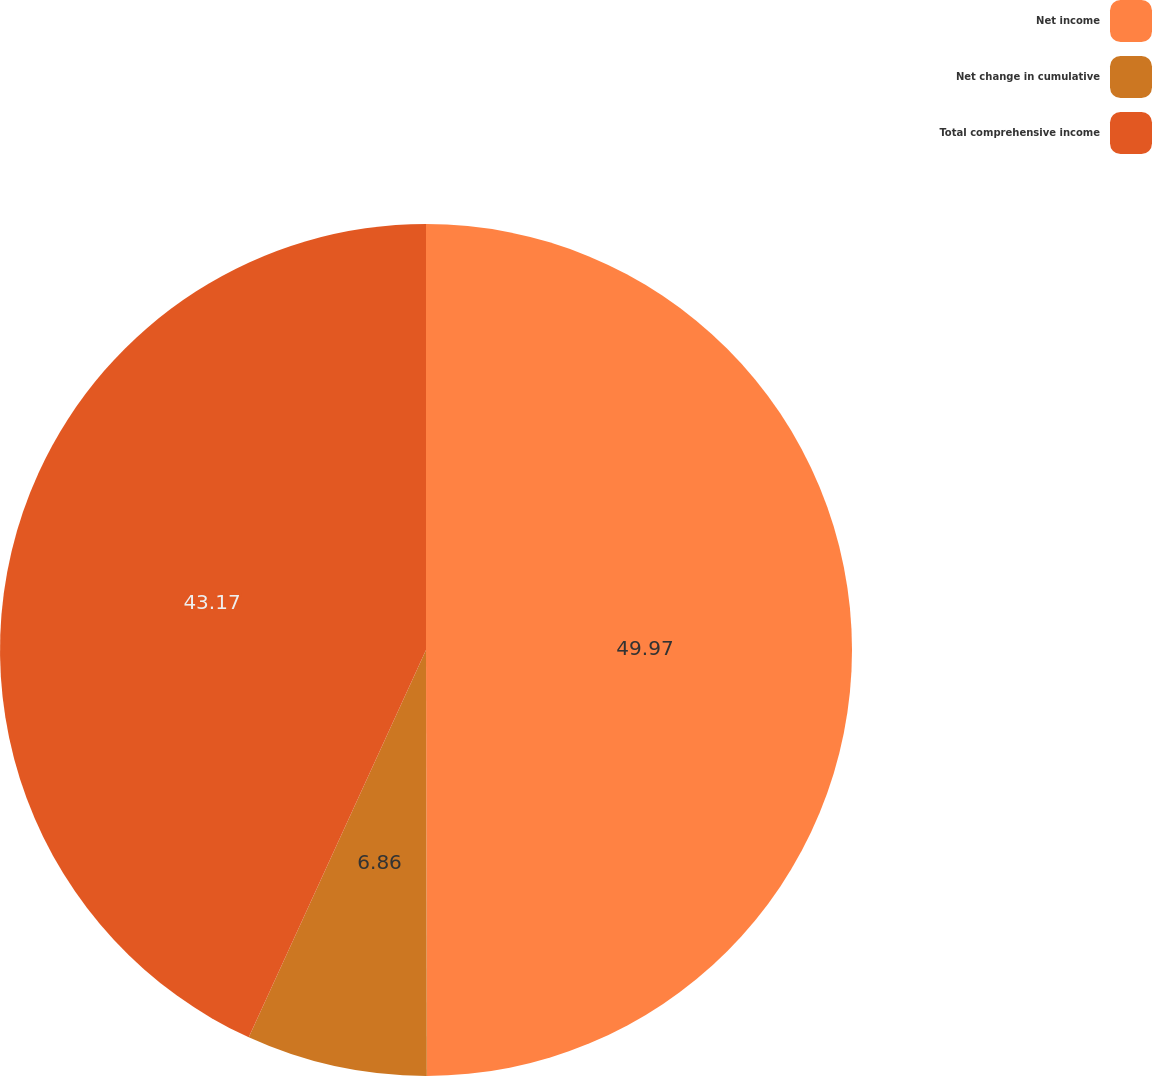Convert chart to OTSL. <chart><loc_0><loc_0><loc_500><loc_500><pie_chart><fcel>Net income<fcel>Net change in cumulative<fcel>Total comprehensive income<nl><fcel>49.97%<fcel>6.86%<fcel>43.17%<nl></chart> 